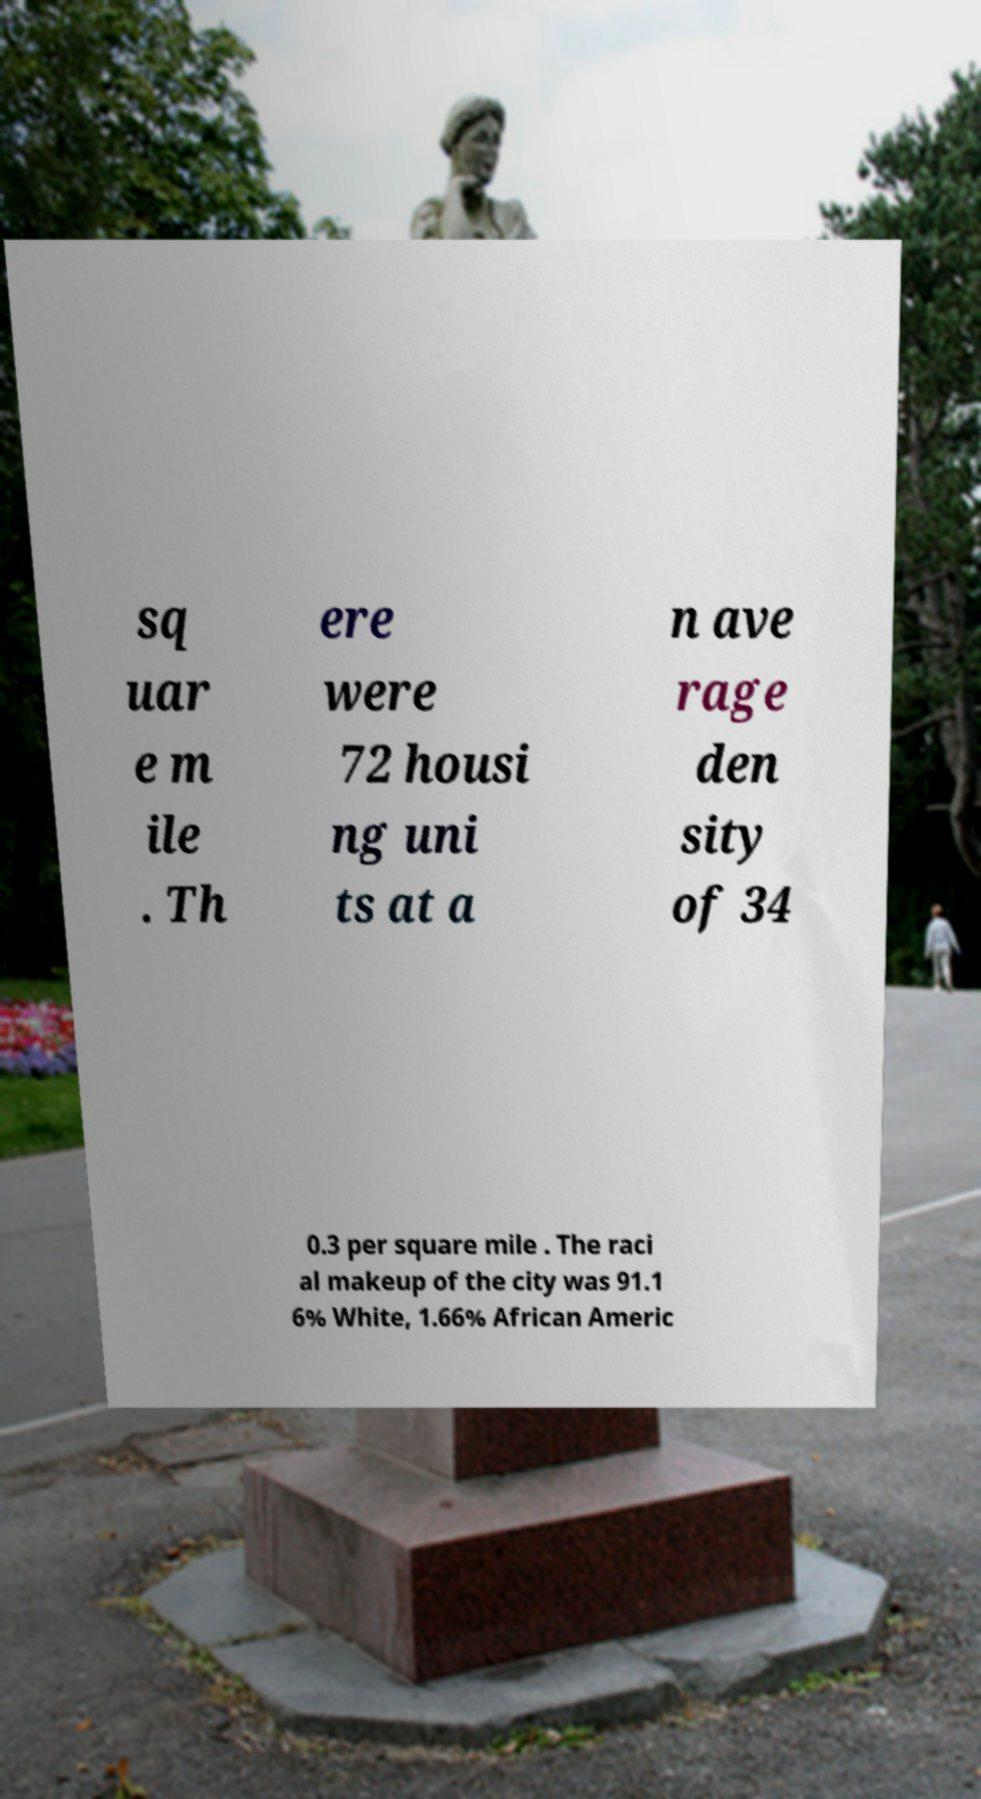What messages or text are displayed in this image? I need them in a readable, typed format. sq uar e m ile . Th ere were 72 housi ng uni ts at a n ave rage den sity of 34 0.3 per square mile . The raci al makeup of the city was 91.1 6% White, 1.66% African Americ 